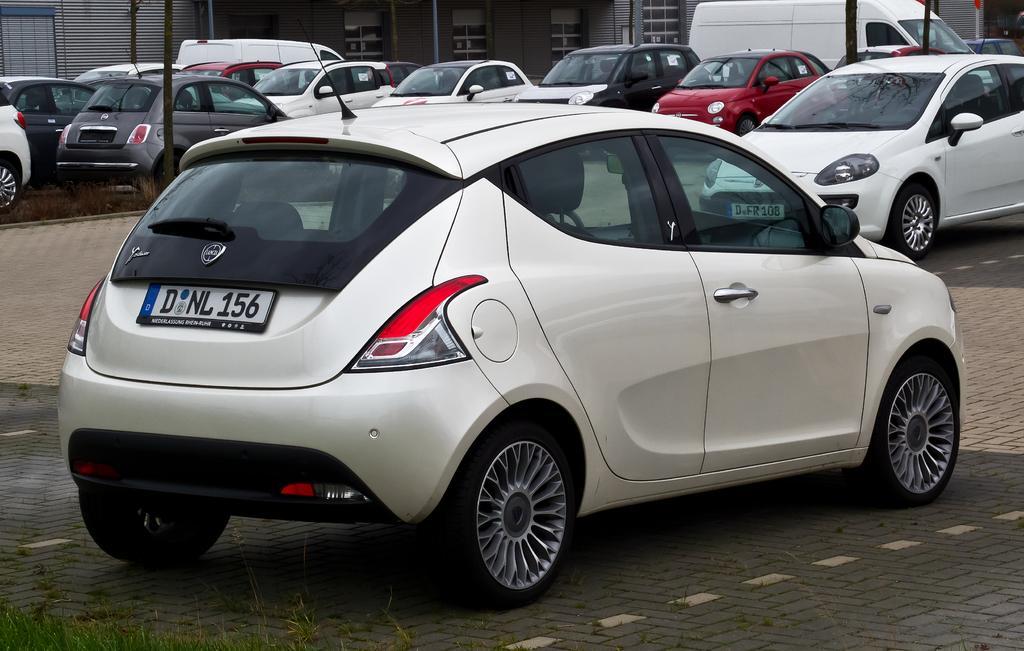In one or two sentences, can you explain what this image depicts? In this picture we can see some cars, on the left side there is grass and a pole, in the background we can see a building and two vans. 